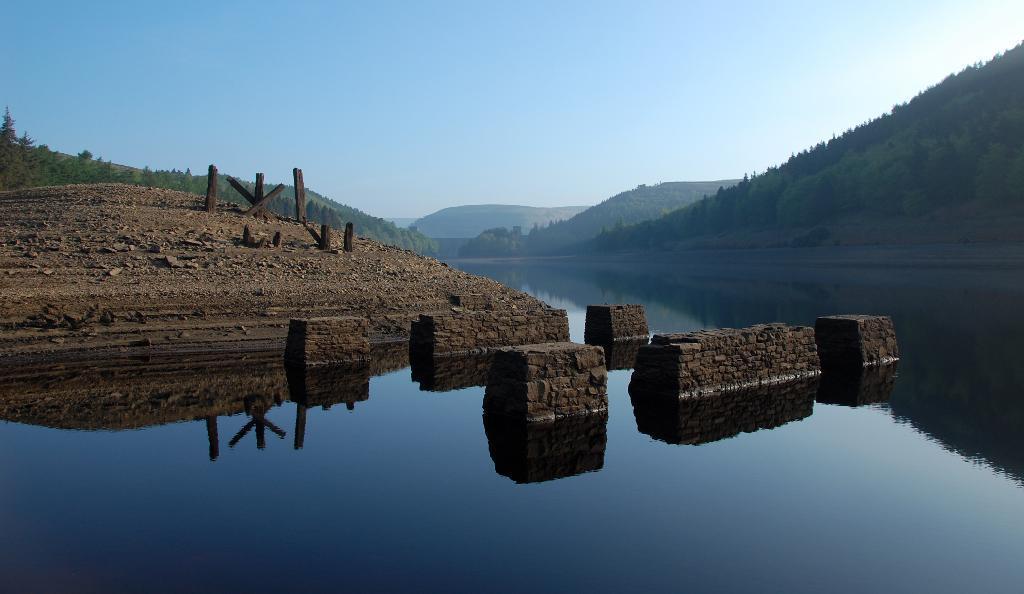How would you summarize this image in a sentence or two? In this picture I can see there is a river and there is a mountain and the mountains are covered with trees and the sky is clear. 